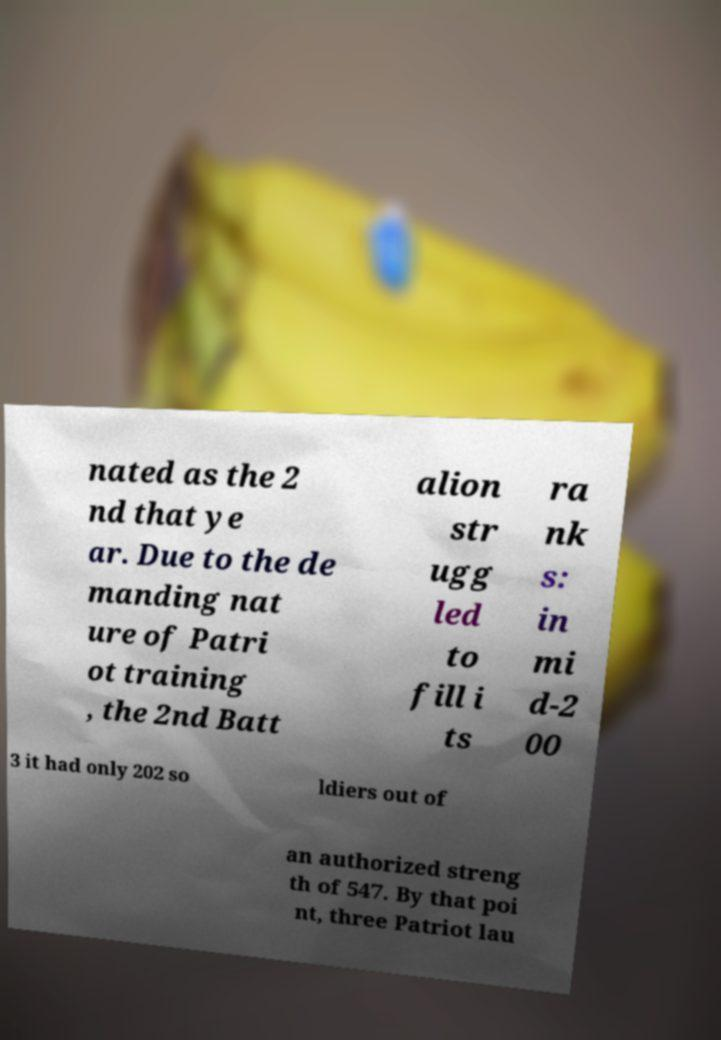Could you extract and type out the text from this image? nated as the 2 nd that ye ar. Due to the de manding nat ure of Patri ot training , the 2nd Batt alion str ugg led to fill i ts ra nk s: in mi d-2 00 3 it had only 202 so ldiers out of an authorized streng th of 547. By that poi nt, three Patriot lau 